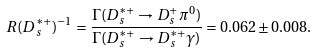Convert formula to latex. <formula><loc_0><loc_0><loc_500><loc_500>R ( D _ { s } ^ { * + } ) ^ { - 1 } = \frac { \Gamma ( D _ { s } ^ { * + } \rightarrow D _ { s } ^ { + } \pi ^ { 0 } ) } { \Gamma ( D _ { s } ^ { * + } \rightarrow D _ { s } ^ { * + } \gamma ) } = 0 . 0 6 2 \pm 0 . 0 0 8 .</formula> 